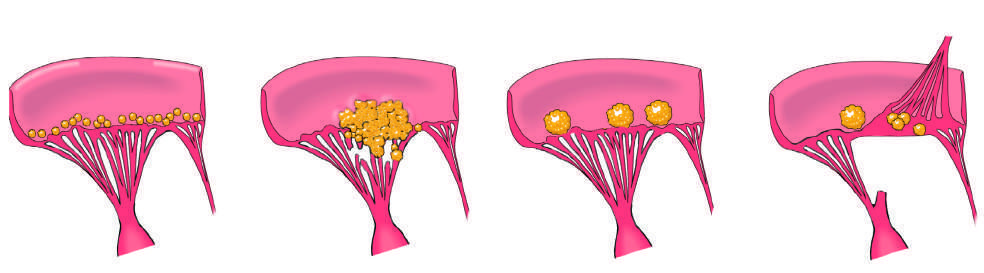what heals with scarring?
Answer the question using a single word or phrase. Small- to medium-sized inflammatory vegetations caused by libman-sacks endocarditis (lse) 